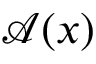<formula> <loc_0><loc_0><loc_500><loc_500>\mathcal { A } ( x )</formula> 